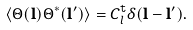Convert formula to latex. <formula><loc_0><loc_0><loc_500><loc_500>\left \langle \Theta ( \mathbf l ) \Theta ^ { * } ( \mathbf l ^ { \prime } ) \right \rangle = C _ { l } ^ { \tt t } \delta ( \mathbf l - \mathbf l ^ { \prime } ) .</formula> 